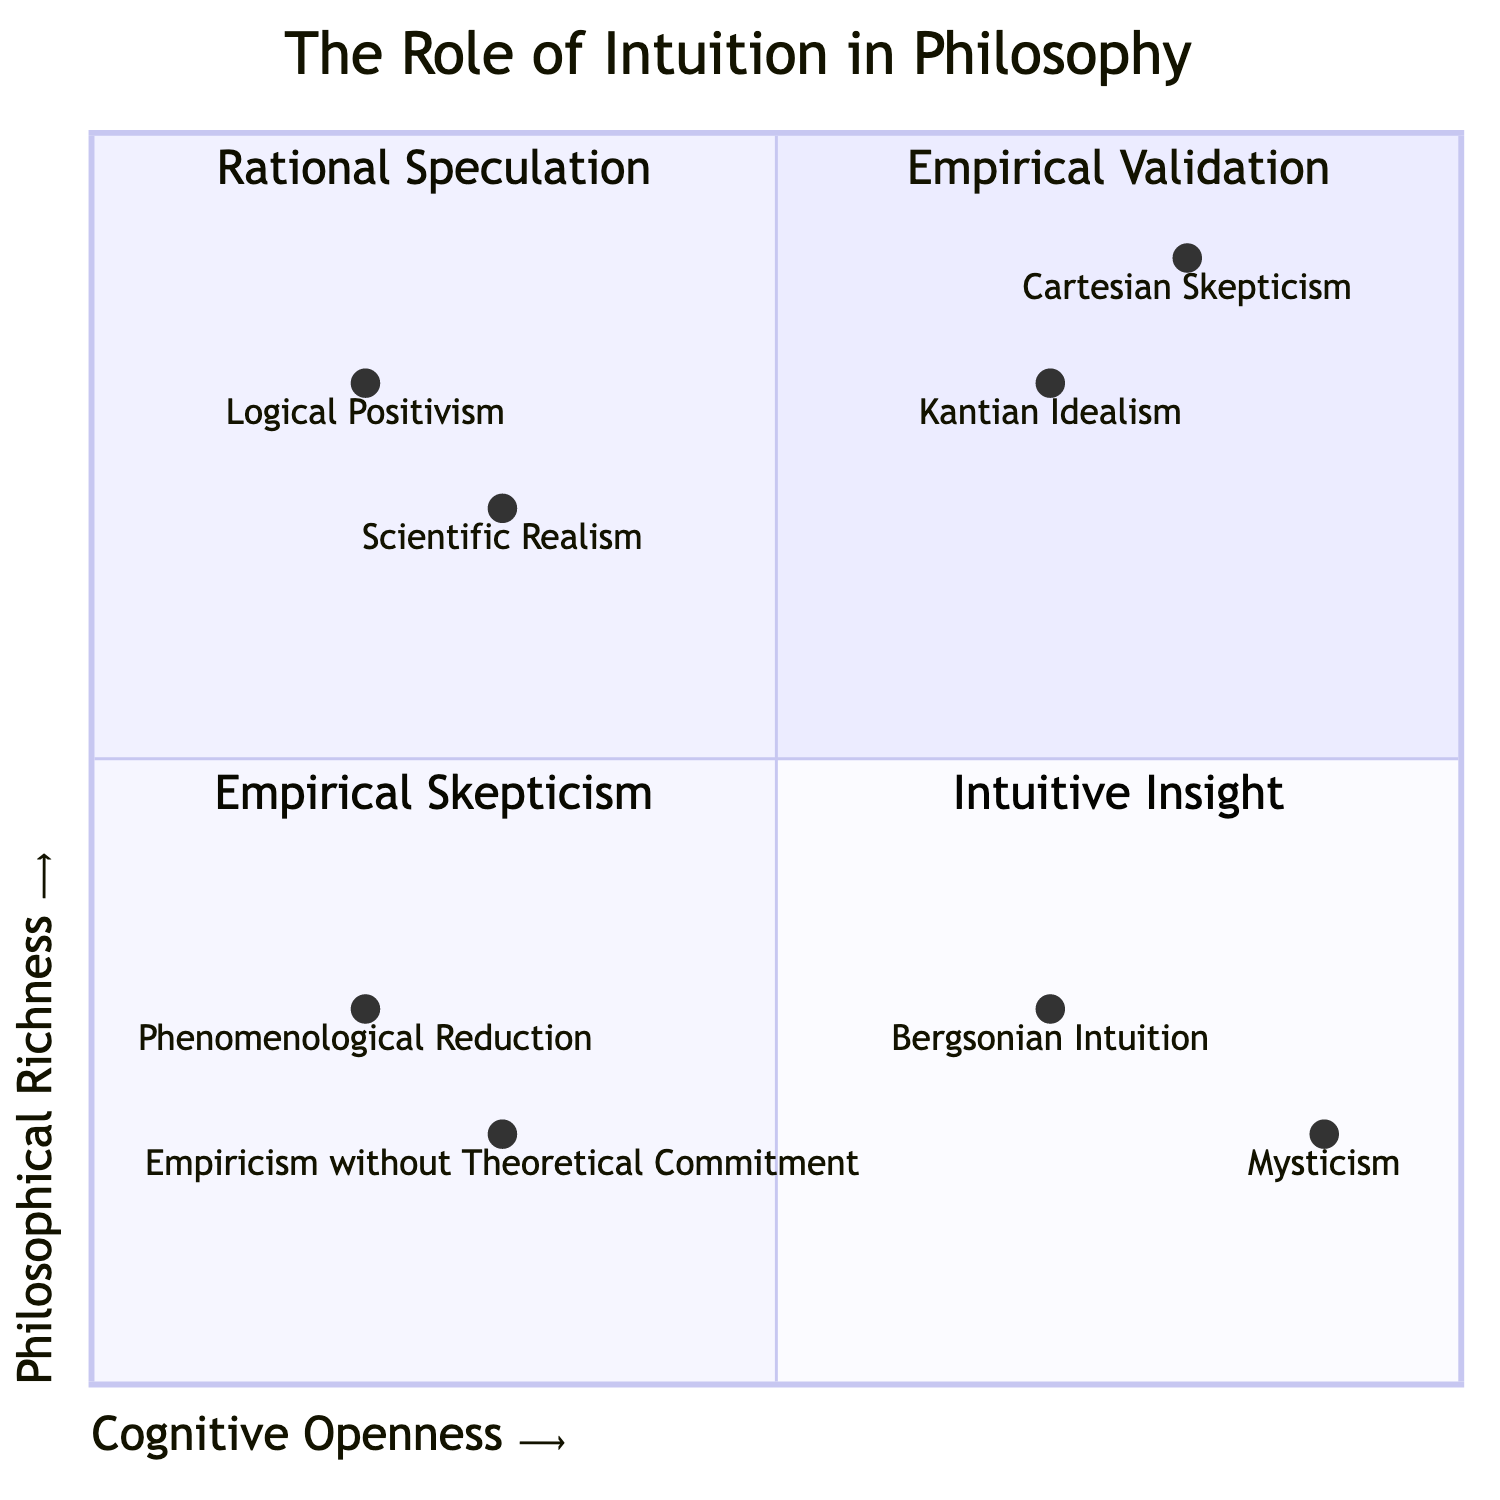What is the y-axis label? The y-axis represents "Philosophical Richness," which indicates the level of depth and complexity in philosophical ideas related to the concepts illustrated in the chart.
Answer: Philosophical Richness Which quadrant contains Logical Positivism? Logical Positivism is positioned in Quadrant 1 (Empirical Validation) where there is low Cognitive Openness and high Philosophical Richness.
Answer: Empirical Validation How many quadrants are displayed in the chart? The chart presents a total of four distinct quadrants, each representing a unique relationship between Cognitive Openness and Philosophical Richness.
Answer: 4 What is the main characteristic of Quadrant 4? Quadrant 4 (Intuitive Insight) is characterized by high Cognitive Openness but low Philosophical Richness, indicating a willingness to explore ideas without substantial philosophical depth.
Answer: High Cognitive Openness, Low Philosophical Richness What examples are found in the Rational Speculation quadrant? The Rational Speculation quadrant contains examples such as Cartesian Skepticism and Kantian Idealism, both of which exhibit high levels of both Cognitive Openness and Philosophical Richness.
Answer: Cartesian Skepticism, Kantian Idealism Which philosophical concepts fall into the category of Empirical Skepticism? The examples located in Quadrant 3 (Empirical Skepticism) include "Empiricism without Theoretical Commitment" and "Phenomenological Reduction," which illustrate low Cognitive Openness and low Philosophical Richness.
Answer: Empiricism without Theoretical Commitment, Phenomenological Reduction Which quadrant has the highest level of Cognitive Openness? Quadrant 2 (Rational Speculation) exhibits the highest level of Cognitive Openness, which aligns with its designation as a space for high philosophical depth and speculative thought.
Answer: Rational Speculation How would you describe the relationship between Intuitive Insight and Empirical Validation? Intuitive Insight (Quadrant 4) has high Cognitive Openness with low Philosophical Richness, whereas Empirical Validation (Quadrant 1) has low Cognitive Openness and high Philosophical Richness; they represent opposite ends of the cognitive spectrum regarding philosophical approaches.
Answer: Opposite ends of the cognitive spectrum 